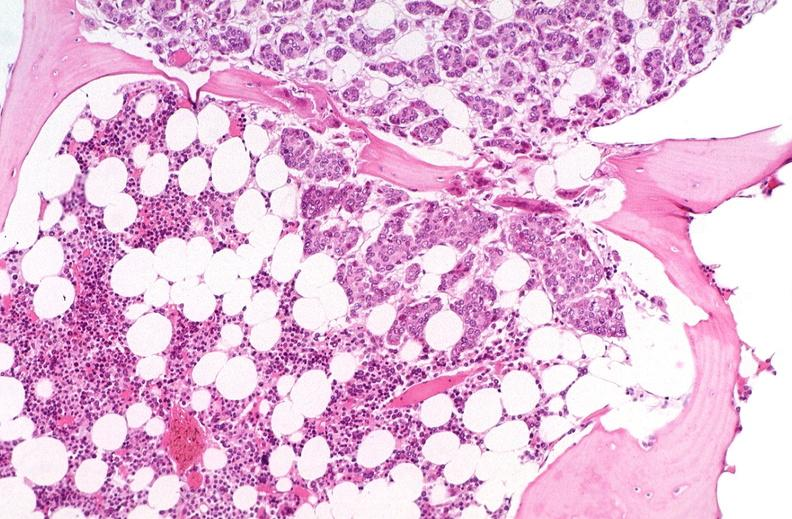does this image show breast cancer metastasis to bone marrow?
Answer the question using a single word or phrase. Yes 